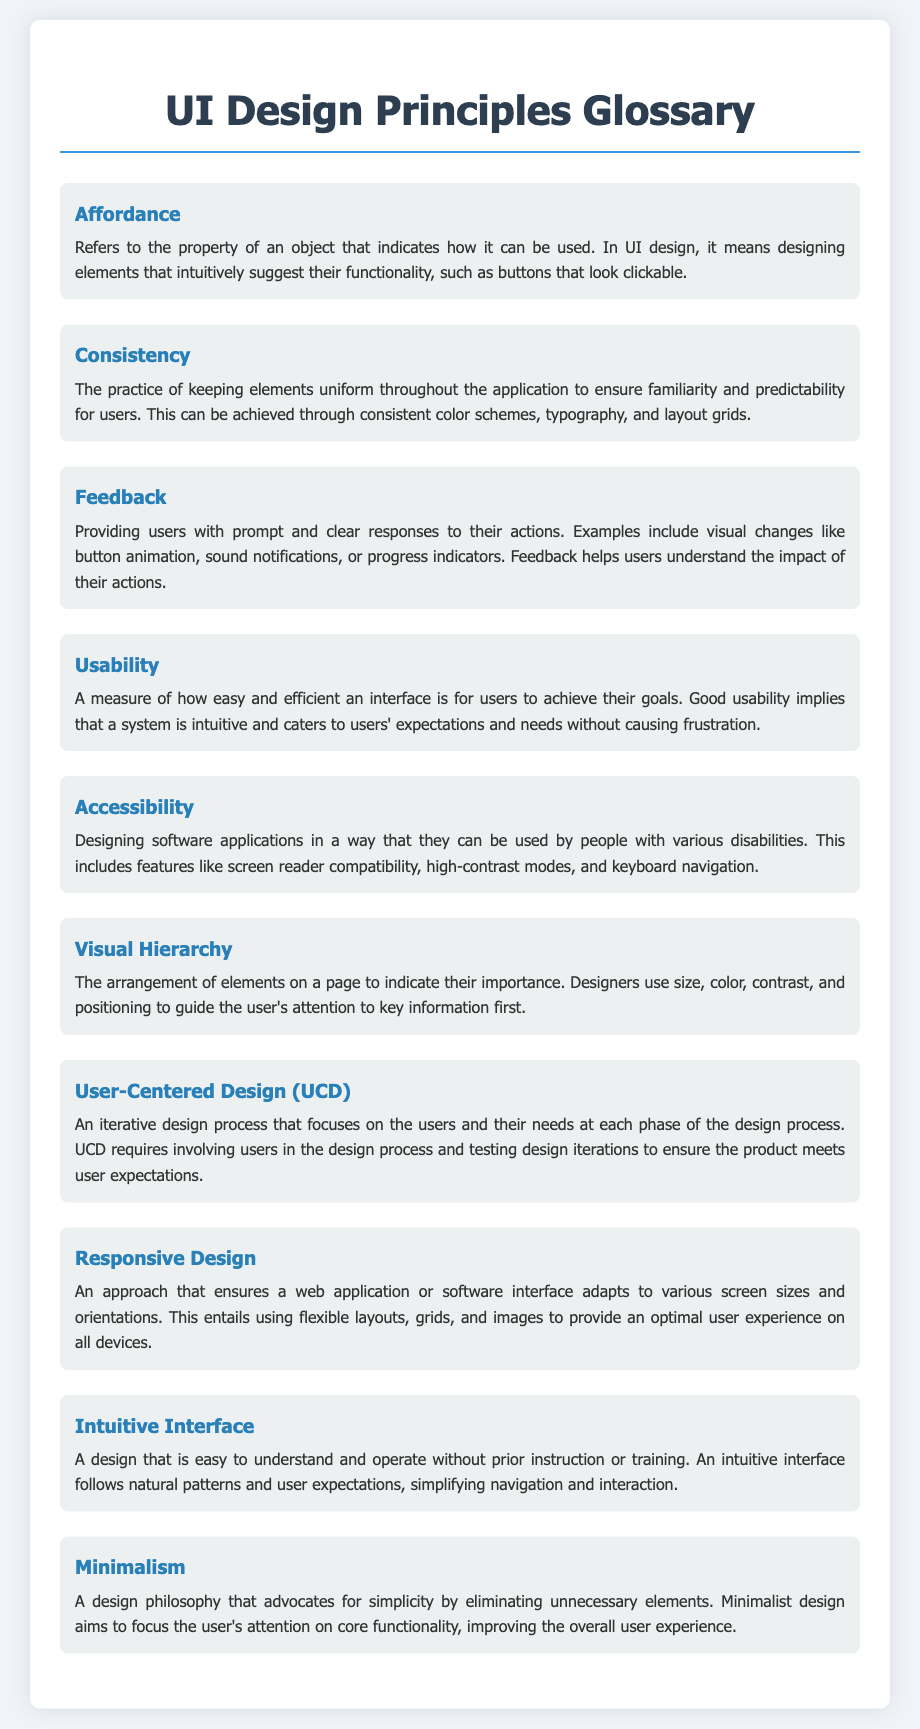what is the term for the property of an object that indicates how it can be used? The term defined in the document for this property is "Affordance."
Answer: Affordance what principle involves keeping elements uniform throughout the application? Consistency in the document refers to the practice of maintaining uniformity in elements.
Answer: Consistency what is the importance of providing users with prompt and clear responses to their actions? The document states that this practice is referred to as "Feedback."
Answer: Feedback what does good usability imply about a system? According to the document, good usability implies that a system is intuitive and caters to users' expectations and needs without causing frustration.
Answer: Intuitive what does the term "Accessibility" refer to in UI design? Accessibility refers to designing applications so they can be used by people with various disabilities.
Answer: Disabilities which design principle uses size, color, contrast, and positioning to guide user attention? The document explains that "Visual Hierarchy" is used to arrange elements for this purpose.
Answer: Visual Hierarchy how many key principles are listed in the glossary? The document lists a total of ten different principles related to UI design.
Answer: Ten what iterative design process focuses on users and their needs? The process outlined in the document is called "User-Centered Design (UCD)."
Answer: User-Centered Design (UCD) what approach ensures software adapts to various screen sizes? The document describes this approach as "Responsive Design."
Answer: Responsive Design 